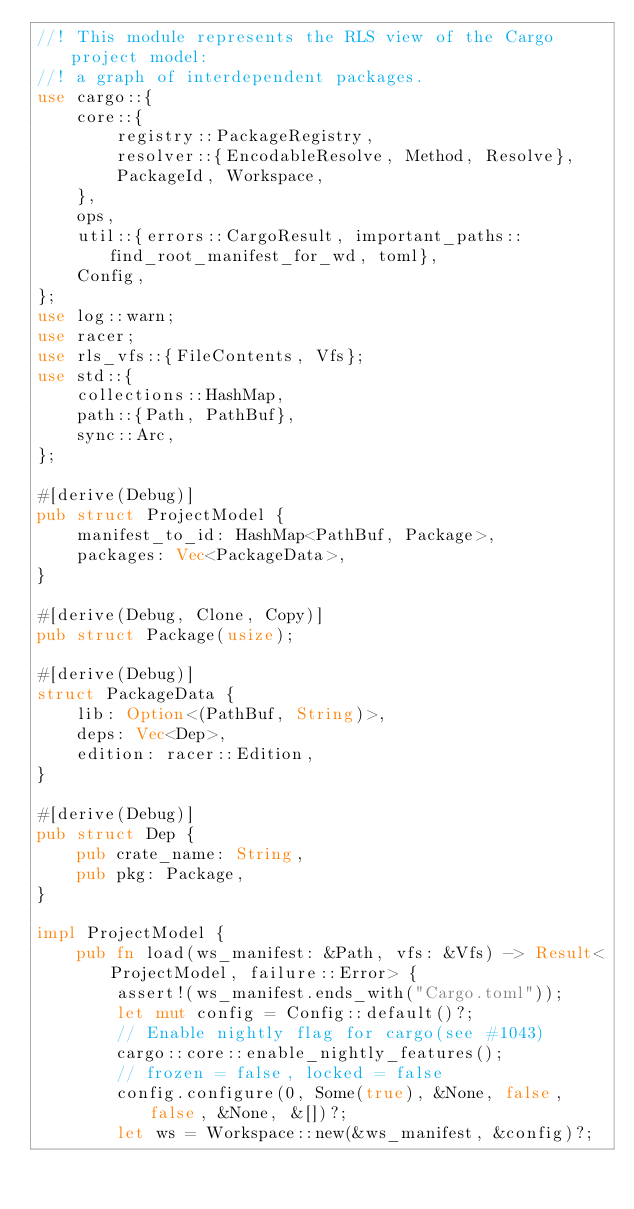Convert code to text. <code><loc_0><loc_0><loc_500><loc_500><_Rust_>//! This module represents the RLS view of the Cargo project model:
//! a graph of interdependent packages.
use cargo::{
    core::{
        registry::PackageRegistry,
        resolver::{EncodableResolve, Method, Resolve},
        PackageId, Workspace,
    },
    ops,
    util::{errors::CargoResult, important_paths::find_root_manifest_for_wd, toml},
    Config,
};
use log::warn;
use racer;
use rls_vfs::{FileContents, Vfs};
use std::{
    collections::HashMap,
    path::{Path, PathBuf},
    sync::Arc,
};

#[derive(Debug)]
pub struct ProjectModel {
    manifest_to_id: HashMap<PathBuf, Package>,
    packages: Vec<PackageData>,
}

#[derive(Debug, Clone, Copy)]
pub struct Package(usize);

#[derive(Debug)]
struct PackageData {
    lib: Option<(PathBuf, String)>,
    deps: Vec<Dep>,
    edition: racer::Edition,
}

#[derive(Debug)]
pub struct Dep {
    pub crate_name: String,
    pub pkg: Package,
}

impl ProjectModel {
    pub fn load(ws_manifest: &Path, vfs: &Vfs) -> Result<ProjectModel, failure::Error> {
        assert!(ws_manifest.ends_with("Cargo.toml"));
        let mut config = Config::default()?;
        // Enable nightly flag for cargo(see #1043)
        cargo::core::enable_nightly_features();
        // frozen = false, locked = false
        config.configure(0, Some(true), &None, false, false, &None, &[])?;
        let ws = Workspace::new(&ws_manifest, &config)?;</code> 